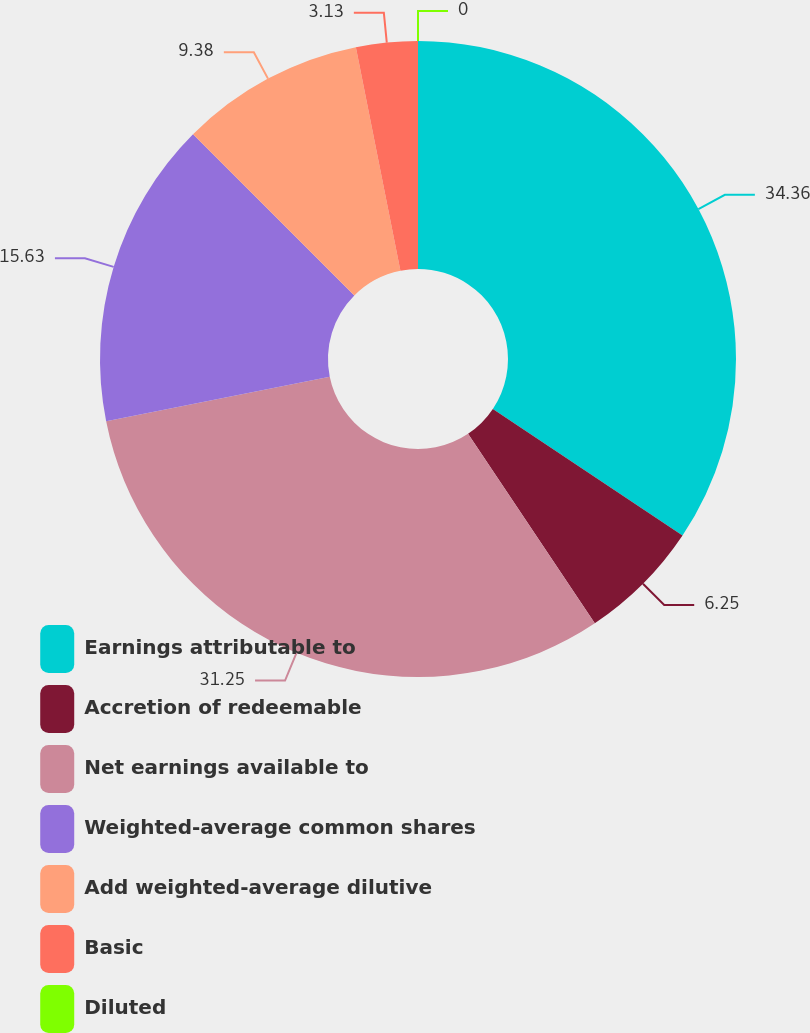Convert chart to OTSL. <chart><loc_0><loc_0><loc_500><loc_500><pie_chart><fcel>Earnings attributable to<fcel>Accretion of redeemable<fcel>Net earnings available to<fcel>Weighted-average common shares<fcel>Add weighted-average dilutive<fcel>Basic<fcel>Diluted<nl><fcel>34.37%<fcel>6.25%<fcel>31.25%<fcel>15.63%<fcel>9.38%<fcel>3.13%<fcel>0.0%<nl></chart> 